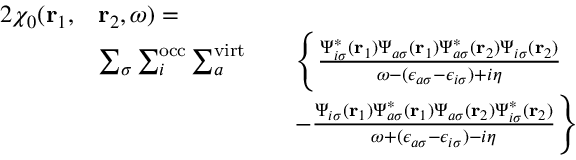<formula> <loc_0><loc_0><loc_500><loc_500>\begin{array} { r l r l } { { 2 } \chi _ { 0 } ( r _ { 1 } , } & { r _ { 2 } , \omega ) = } \\ & { \sum _ { \sigma } \sum _ { i } ^ { o c c } \sum _ { a } ^ { v i r t } } & & { \left \{ \frac { \Psi _ { i \sigma } ^ { * } ( r _ { 1 } ) \Psi _ { a \sigma } ( r _ { 1 } ) \Psi _ { a \sigma } ^ { * } ( r _ { 2 } ) \Psi _ { i \sigma } ( r _ { 2 } ) } { \omega - ( \epsilon _ { a \sigma } - \epsilon _ { i \sigma } ) + i \eta } } \\ & & { - \frac { \Psi _ { i \sigma } ( r _ { 1 } ) \Psi _ { a \sigma } ^ { * } ( r _ { 1 } ) \Psi _ { a \sigma } ( r _ { 2 } ) \Psi _ { i \sigma } ^ { * } ( r _ { 2 } ) } { \omega + ( \epsilon _ { a \sigma } - \epsilon _ { i \sigma } ) - i \eta } \right \} } \end{array}</formula> 